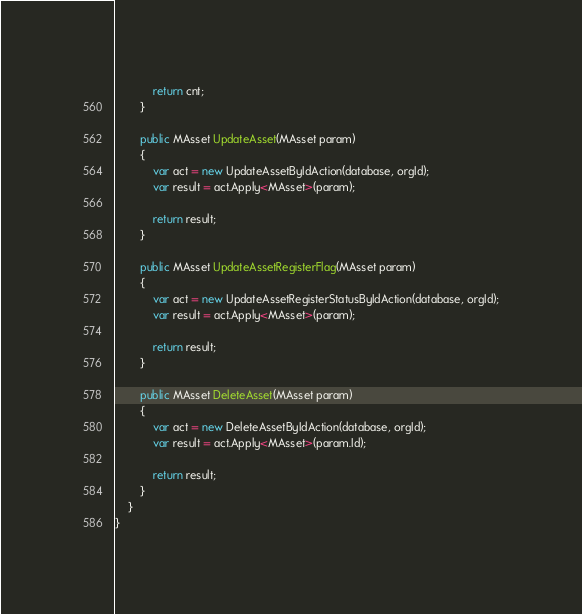<code> <loc_0><loc_0><loc_500><loc_500><_C#_>            return cnt;
        }

        public MAsset UpdateAsset(MAsset param)
        {
            var act = new UpdateAssetByIdAction(database, orgId);
            var result = act.Apply<MAsset>(param);

            return result;
        }

        public MAsset UpdateAssetRegisterFlag(MAsset param)
        {
            var act = new UpdateAssetRegisterStatusByIdAction(database, orgId);
            var result = act.Apply<MAsset>(param);

            return result;
        }

        public MAsset DeleteAsset(MAsset param)
        {
            var act = new DeleteAssetByIdAction(database, orgId);
            var result = act.Apply<MAsset>(param.Id);

            return result;
        }
    }
}
</code> 